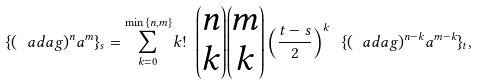<formula> <loc_0><loc_0><loc_500><loc_500>\{ ( \ a d a g ) ^ { n } a ^ { m } \} _ { s } = \sum _ { k = 0 } ^ { \min { \{ n , m \} } } k ! \ { \begin{pmatrix} n \\ k \end{pmatrix} } { \begin{pmatrix} m \\ k \end{pmatrix} } \left ( \frac { t - s } { 2 } \right ) ^ { k } \ \{ ( \ a d a g ) ^ { n - k } a ^ { m - k } \} _ { t } ,</formula> 